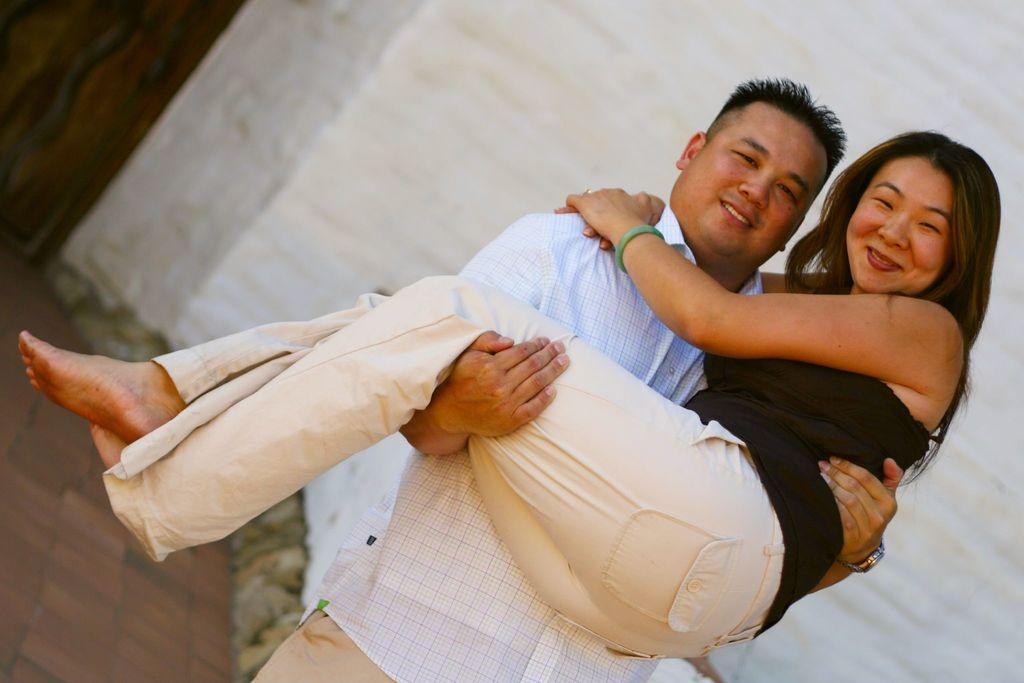How many people are in the image? There are two persons in the image. What is the man doing in the image? The man is carrying a lady in the image. What is the distance between the prison and the location of the image? There is no reference to a prison in the image, so it is not possible to determine the distance between the prison and the location of the image. 